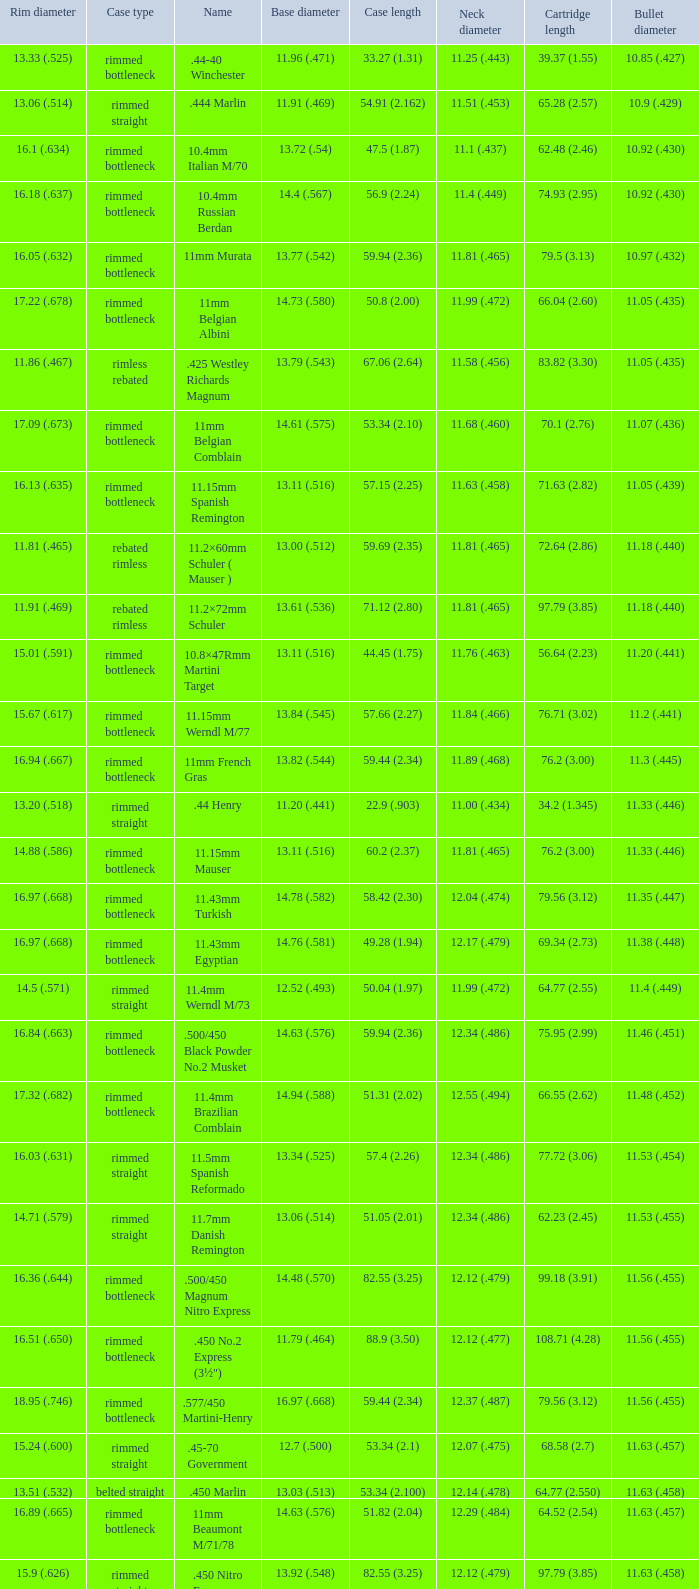Can you give me this table as a dict? {'header': ['Rim diameter', 'Case type', 'Name', 'Base diameter', 'Case length', 'Neck diameter', 'Cartridge length', 'Bullet diameter'], 'rows': [['13.33 (.525)', 'rimmed bottleneck', '.44-40 Winchester', '11.96 (.471)', '33.27 (1.31)', '11.25 (.443)', '39.37 (1.55)', '10.85 (.427)'], ['13.06 (.514)', 'rimmed straight', '.444 Marlin', '11.91 (.469)', '54.91 (2.162)', '11.51 (.453)', '65.28 (2.57)', '10.9 (.429)'], ['16.1 (.634)', 'rimmed bottleneck', '10.4mm Italian M/70', '13.72 (.54)', '47.5 (1.87)', '11.1 (.437)', '62.48 (2.46)', '10.92 (.430)'], ['16.18 (.637)', 'rimmed bottleneck', '10.4mm Russian Berdan', '14.4 (.567)', '56.9 (2.24)', '11.4 (.449)', '74.93 (2.95)', '10.92 (.430)'], ['16.05 (.632)', 'rimmed bottleneck', '11mm Murata', '13.77 (.542)', '59.94 (2.36)', '11.81 (.465)', '79.5 (3.13)', '10.97 (.432)'], ['17.22 (.678)', 'rimmed bottleneck', '11mm Belgian Albini', '14.73 (.580)', '50.8 (2.00)', '11.99 (.472)', '66.04 (2.60)', '11.05 (.435)'], ['11.86 (.467)', 'rimless rebated', '.425 Westley Richards Magnum', '13.79 (.543)', '67.06 (2.64)', '11.58 (.456)', '83.82 (3.30)', '11.05 (.435)'], ['17.09 (.673)', 'rimmed bottleneck', '11mm Belgian Comblain', '14.61 (.575)', '53.34 (2.10)', '11.68 (.460)', '70.1 (2.76)', '11.07 (.436)'], ['16.13 (.635)', 'rimmed bottleneck', '11.15mm Spanish Remington', '13.11 (.516)', '57.15 (2.25)', '11.63 (.458)', '71.63 (2.82)', '11.05 (.439)'], ['11.81 (.465)', 'rebated rimless', '11.2×60mm Schuler ( Mauser )', '13.00 (.512)', '59.69 (2.35)', '11.81 (.465)', '72.64 (2.86)', '11.18 (.440)'], ['11.91 (.469)', 'rebated rimless', '11.2×72mm Schuler', '13.61 (.536)', '71.12 (2.80)', '11.81 (.465)', '97.79 (3.85)', '11.18 (.440)'], ['15.01 (.591)', 'rimmed bottleneck', '10.8×47Rmm Martini Target', '13.11 (.516)', '44.45 (1.75)', '11.76 (.463)', '56.64 (2.23)', '11.20 (.441)'], ['15.67 (.617)', 'rimmed bottleneck', '11.15mm Werndl M/77', '13.84 (.545)', '57.66 (2.27)', '11.84 (.466)', '76.71 (3.02)', '11.2 (.441)'], ['16.94 (.667)', 'rimmed bottleneck', '11mm French Gras', '13.82 (.544)', '59.44 (2.34)', '11.89 (.468)', '76.2 (3.00)', '11.3 (.445)'], ['13.20 (.518)', 'rimmed straight', '.44 Henry', '11.20 (.441)', '22.9 (.903)', '11.00 (.434)', '34.2 (1.345)', '11.33 (.446)'], ['14.88 (.586)', 'rimmed bottleneck', '11.15mm Mauser', '13.11 (.516)', '60.2 (2.37)', '11.81 (.465)', '76.2 (3.00)', '11.33 (.446)'], ['16.97 (.668)', 'rimmed bottleneck', '11.43mm Turkish', '14.78 (.582)', '58.42 (2.30)', '12.04 (.474)', '79.56 (3.12)', '11.35 (.447)'], ['16.97 (.668)', 'rimmed bottleneck', '11.43mm Egyptian', '14.76 (.581)', '49.28 (1.94)', '12.17 (.479)', '69.34 (2.73)', '11.38 (.448)'], ['14.5 (.571)', 'rimmed straight', '11.4mm Werndl M/73', '12.52 (.493)', '50.04 (1.97)', '11.99 (.472)', '64.77 (2.55)', '11.4 (.449)'], ['16.84 (.663)', 'rimmed bottleneck', '.500/450 Black Powder No.2 Musket', '14.63 (.576)', '59.94 (2.36)', '12.34 (.486)', '75.95 (2.99)', '11.46 (.451)'], ['17.32 (.682)', 'rimmed bottleneck', '11.4mm Brazilian Comblain', '14.94 (.588)', '51.31 (2.02)', '12.55 (.494)', '66.55 (2.62)', '11.48 (.452)'], ['16.03 (.631)', 'rimmed straight', '11.5mm Spanish Reformado', '13.34 (.525)', '57.4 (2.26)', '12.34 (.486)', '77.72 (3.06)', '11.53 (.454)'], ['14.71 (.579)', 'rimmed straight', '11.7mm Danish Remington', '13.06 (.514)', '51.05 (2.01)', '12.34 (.486)', '62.23 (2.45)', '11.53 (.455)'], ['16.36 (.644)', 'rimmed bottleneck', '.500/450 Magnum Nitro Express', '14.48 (.570)', '82.55 (3.25)', '12.12 (.479)', '99.18 (3.91)', '11.56 (.455)'], ['16.51 (.650)', 'rimmed bottleneck', '.450 No.2 Express (3½")', '11.79 (.464)', '88.9 (3.50)', '12.12 (.477)', '108.71 (4.28)', '11.56 (.455)'], ['18.95 (.746)', 'rimmed bottleneck', '.577/450 Martini-Henry', '16.97 (.668)', '59.44 (2.34)', '12.37 (.487)', '79.56 (3.12)', '11.56 (.455)'], ['15.24 (.600)', 'rimmed straight', '.45-70 Government', '12.7 (.500)', '53.34 (2.1)', '12.07 (.475)', '68.58 (2.7)', '11.63 (.457)'], ['13.51 (.532)', 'belted straight', '.450 Marlin', '13.03 (.513)', '53.34 (2.100)', '12.14 (.478)', '64.77 (2.550)', '11.63 (.458)'], ['16.89 (.665)', 'rimmed bottleneck', '11mm Beaumont M/71/78', '14.63 (.576)', '51.82 (2.04)', '12.29 (.484)', '64.52 (2.54)', '11.63 (.457)'], ['15.9 (.626)', 'rimmed straight', '.450 Nitro Express (3¼")', '13.92 (.548)', '82.55 (3.25)', '12.12 (.479)', '97.79 (3.85)', '11.63 (.458)'], ['13.51 (.532)', 'belted straight', '.458 Winchester Magnum', '13.03 (.513)', '63.5 (2.5)', '12.14 (.478)', '82.55 (3.350)', '11.63 (.458)'], ['13.54 (.533)', 'belted bottleneck', '.460 Weatherby Magnum', '14.80 (.583)', '74 (2.91)', '12.32 (.485)', '95.25 (3.75)', '11.63 (.458)'], ['16.76 (.660)', 'rimmed bottleneck', '.500/450 No.1 Express', '14.66 (.577)', '69.85 (2.75)', '12.32 (.485)', '82.55 (3.25)', '11.63 (.458)'], ['14.99 (.590)', 'rimless bottleneck', '.450 Rigby Rimless', '14.66 (.577)', '73.50 (2.89)', '12.38 (.487)', '95.00 (3.74)', '11.63 (.458)'], ['16.92 (.666)', 'rimmed bottleneck', '11.3mm Beaumont M/71', '14.76 (.581)', '50.04 (1.97)', '12.34 (.486)', '63.25 (2.49)', '11.63 (.464)'], ['16.51 (.650)', 'rimmed bottleneck', '.500/465 Nitro Express', '14.55 (.573)', '82.3 (3.24)', '12.39 (.488)', '98.04 (3.89)', '11.84 (.466)']]} Which Bullet diameter has a Neck diameter of 12.17 (.479)? 11.38 (.448). 